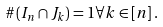Convert formula to latex. <formula><loc_0><loc_0><loc_500><loc_500>\# \left ( I _ { n } \cap J _ { k } \right ) = 1 \forall k \in \left [ n \right ] .</formula> 